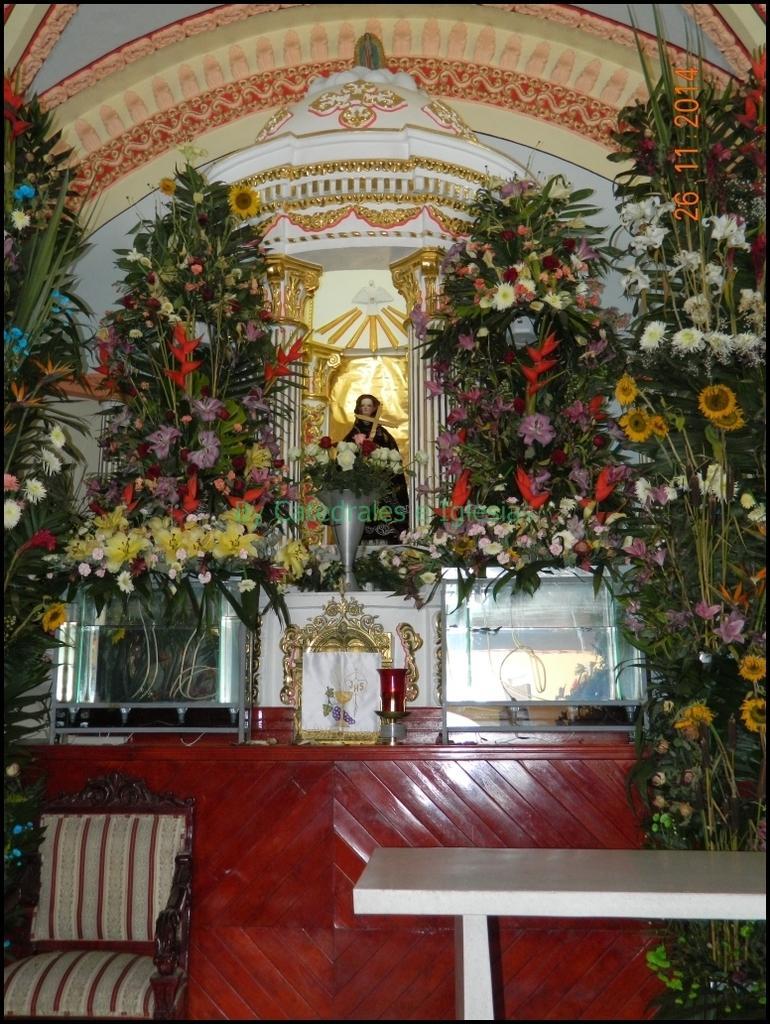Describe this image in one or two sentences. This looks like a sculpture with a holy cross symbol. These are the plants with the colorful flowers. Here is a chair. This looks like a table, which is white in color. I think this is a candle stand. I can see the watermark on the image. This looks like a wall. 